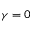<formula> <loc_0><loc_0><loc_500><loc_500>\gamma = 0</formula> 